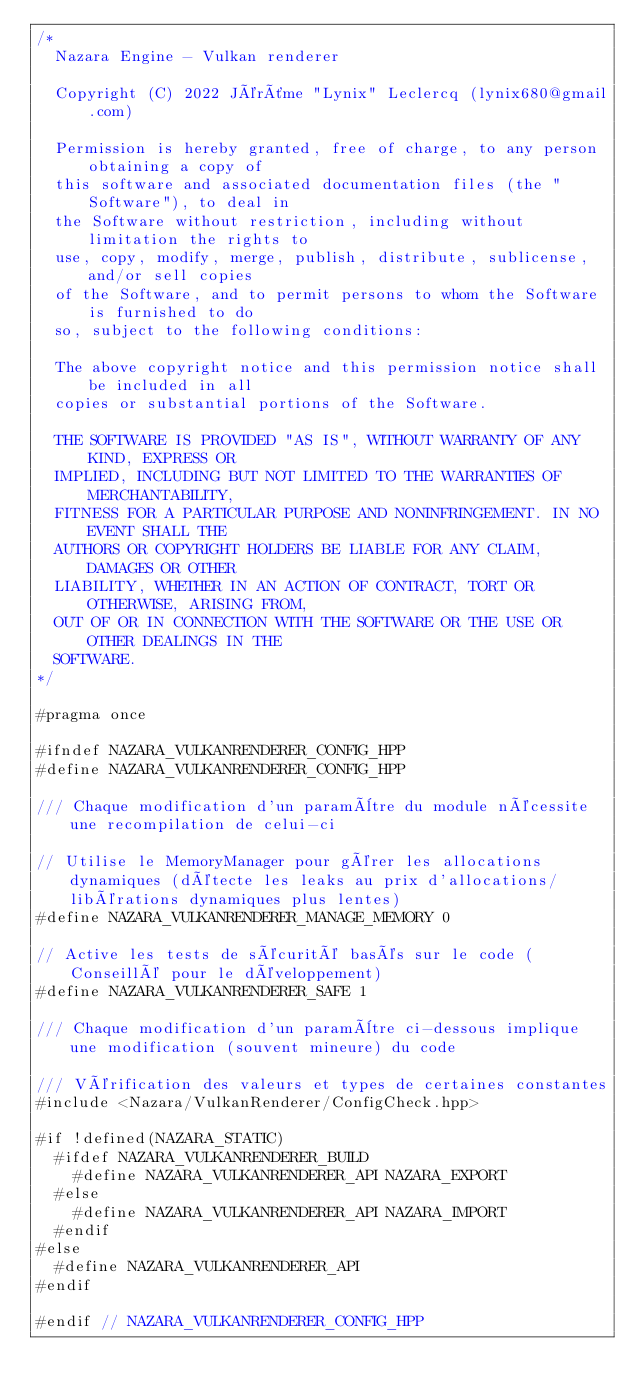Convert code to text. <code><loc_0><loc_0><loc_500><loc_500><_C++_>/*
	Nazara Engine - Vulkan renderer

	Copyright (C) 2022 Jérôme "Lynix" Leclercq (lynix680@gmail.com)

	Permission is hereby granted, free of charge, to any person obtaining a copy of
	this software and associated documentation files (the "Software"), to deal in
	the Software without restriction, including without limitation the rights to
	use, copy, modify, merge, publish, distribute, sublicense, and/or sell copies
	of the Software, and to permit persons to whom the Software is furnished to do
	so, subject to the following conditions:

	The above copyright notice and this permission notice shall be included in all
	copies or substantial portions of the Software.

	THE SOFTWARE IS PROVIDED "AS IS", WITHOUT WARRANTY OF ANY KIND, EXPRESS OR
	IMPLIED, INCLUDING BUT NOT LIMITED TO THE WARRANTIES OF MERCHANTABILITY,
	FITNESS FOR A PARTICULAR PURPOSE AND NONINFRINGEMENT. IN NO EVENT SHALL THE
	AUTHORS OR COPYRIGHT HOLDERS BE LIABLE FOR ANY CLAIM, DAMAGES OR OTHER
	LIABILITY, WHETHER IN AN ACTION OF CONTRACT, TORT OR OTHERWISE, ARISING FROM,
	OUT OF OR IN CONNECTION WITH THE SOFTWARE OR THE USE OR OTHER DEALINGS IN THE
	SOFTWARE.
*/

#pragma once

#ifndef NAZARA_VULKANRENDERER_CONFIG_HPP
#define NAZARA_VULKANRENDERER_CONFIG_HPP

/// Chaque modification d'un paramètre du module nécessite une recompilation de celui-ci

// Utilise le MemoryManager pour gérer les allocations dynamiques (détecte les leaks au prix d'allocations/libérations dynamiques plus lentes)
#define NAZARA_VULKANRENDERER_MANAGE_MEMORY 0

// Active les tests de sécurité basés sur le code (Conseillé pour le développement)
#define NAZARA_VULKANRENDERER_SAFE 1

/// Chaque modification d'un paramètre ci-dessous implique une modification (souvent mineure) du code

/// Vérification des valeurs et types de certaines constantes
#include <Nazara/VulkanRenderer/ConfigCheck.hpp>

#if !defined(NAZARA_STATIC)
	#ifdef NAZARA_VULKANRENDERER_BUILD
		#define NAZARA_VULKANRENDERER_API NAZARA_EXPORT
	#else
		#define NAZARA_VULKANRENDERER_API NAZARA_IMPORT
	#endif
#else
	#define NAZARA_VULKANRENDERER_API
#endif

#endif // NAZARA_VULKANRENDERER_CONFIG_HPP
</code> 